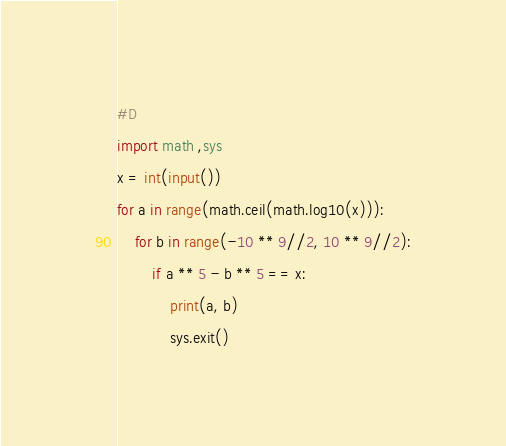<code> <loc_0><loc_0><loc_500><loc_500><_Python_>#D
import math ,sys
x = int(input())
for a in range(math.ceil(math.log10(x))):
    for b in range(-10 ** 9//2, 10 ** 9//2):
        if a ** 5 - b ** 5 == x:
            print(a, b)
            sys.exit()</code> 